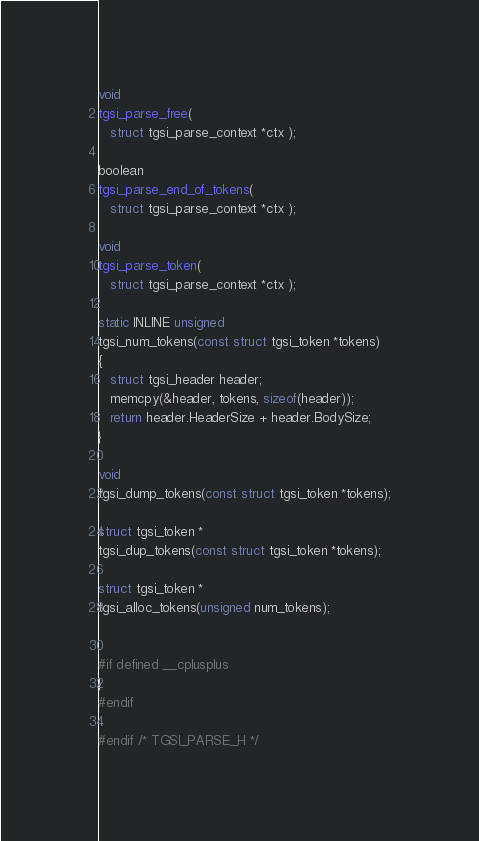Convert code to text. <code><loc_0><loc_0><loc_500><loc_500><_C_>void
tgsi_parse_free(
   struct tgsi_parse_context *ctx );

boolean
tgsi_parse_end_of_tokens(
   struct tgsi_parse_context *ctx );

void
tgsi_parse_token(
   struct tgsi_parse_context *ctx );

static INLINE unsigned
tgsi_num_tokens(const struct tgsi_token *tokens)
{
   struct tgsi_header header;
   memcpy(&header, tokens, sizeof(header));
   return header.HeaderSize + header.BodySize;
}

void
tgsi_dump_tokens(const struct tgsi_token *tokens);

struct tgsi_token *
tgsi_dup_tokens(const struct tgsi_token *tokens);

struct tgsi_token *
tgsi_alloc_tokens(unsigned num_tokens);


#if defined __cplusplus
}
#endif

#endif /* TGSI_PARSE_H */

</code> 